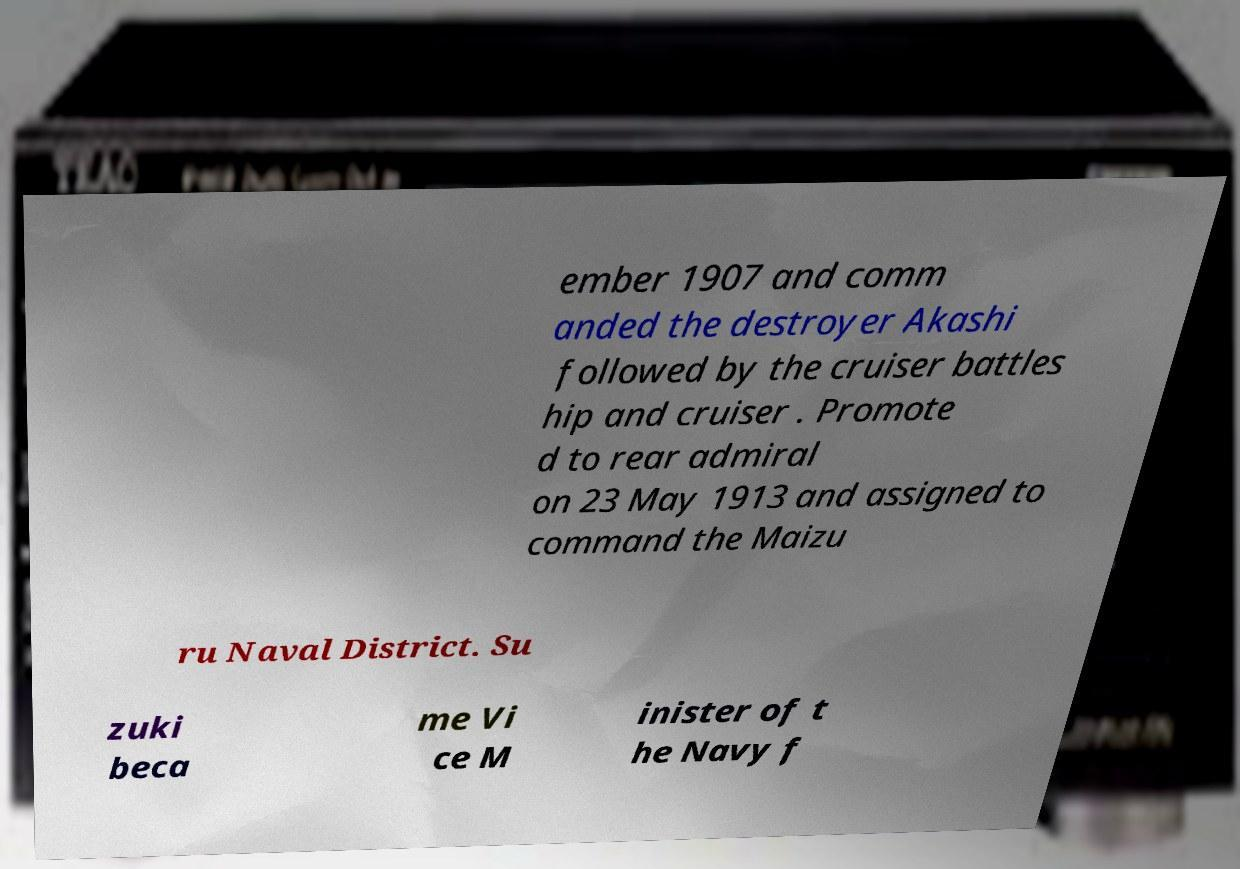Can you accurately transcribe the text from the provided image for me? ember 1907 and comm anded the destroyer Akashi followed by the cruiser battles hip and cruiser . Promote d to rear admiral on 23 May 1913 and assigned to command the Maizu ru Naval District. Su zuki beca me Vi ce M inister of t he Navy f 